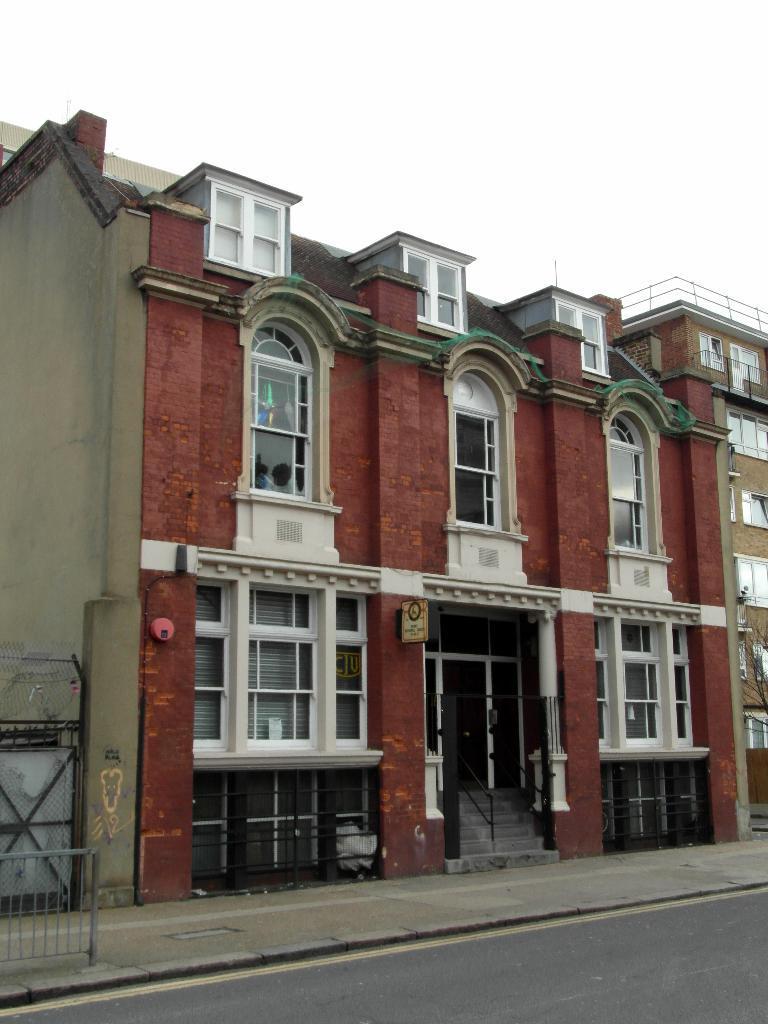How would you summarize this image in a sentence or two? In this image I can see a building along with the windows. At the bottom of the image there is a road. Beside the road I can see railing on the footpath. On the top of the image I can see the sky. 